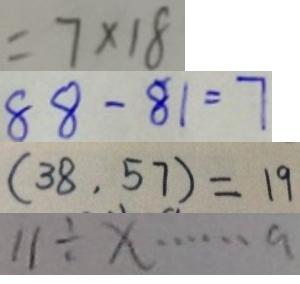<formula> <loc_0><loc_0><loc_500><loc_500>= 7 \times 1 8 
 8 8 - 8 1 = 7 
 ( 3 8 , 5 7 ) = 1 9 
 1 1 \div x \cdots a</formula> 